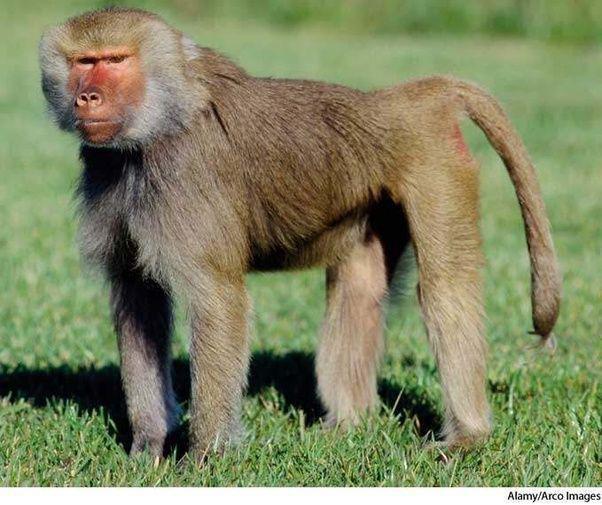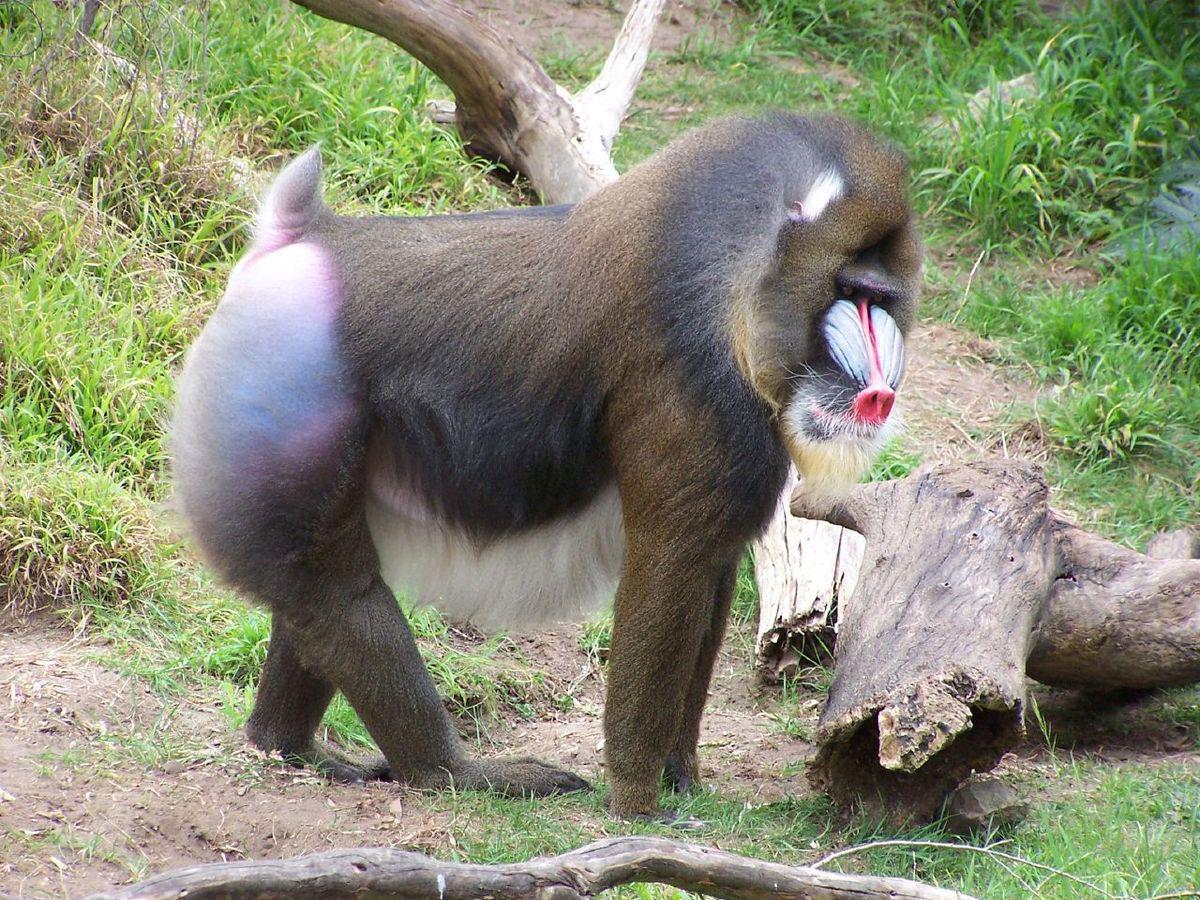The first image is the image on the left, the second image is the image on the right. Given the left and right images, does the statement "Each image contains a single baboon, and all baboons are in standing positions." hold true? Answer yes or no. Yes. The first image is the image on the left, the second image is the image on the right. Examine the images to the left and right. Is the description "There is at least one male sacred baboon." accurate? Answer yes or no. Yes. 